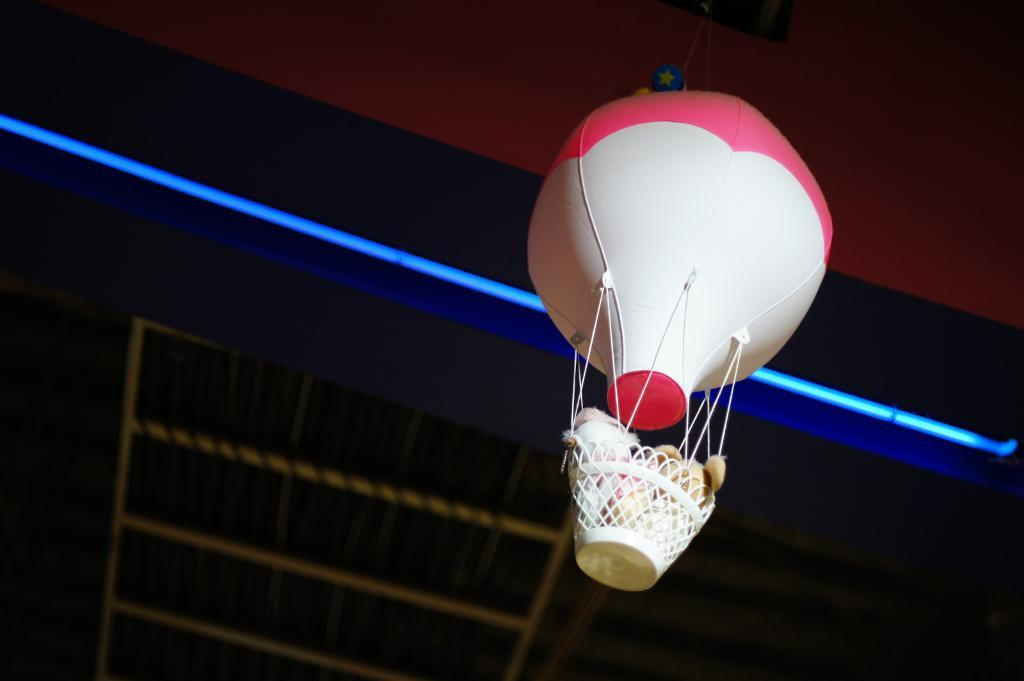What is the main subject of the picture? The main subject of the picture is a hot air balloon. What is attached to the hot air balloon? The hot air balloon has a basket. What can be found inside the basket? There are toys in the basket. What can be seen at the top of the image? There is a light visible at the top of the image. What type of oatmeal is being served in the hot air balloon? There is no oatmeal present in the image; it features a hot air balloon with a basket containing toys. Can you tell me who is playing chess in the hot air balloon? There is no chess game or players visible in the image; it only shows a hot air balloon with a basket containing toys. 